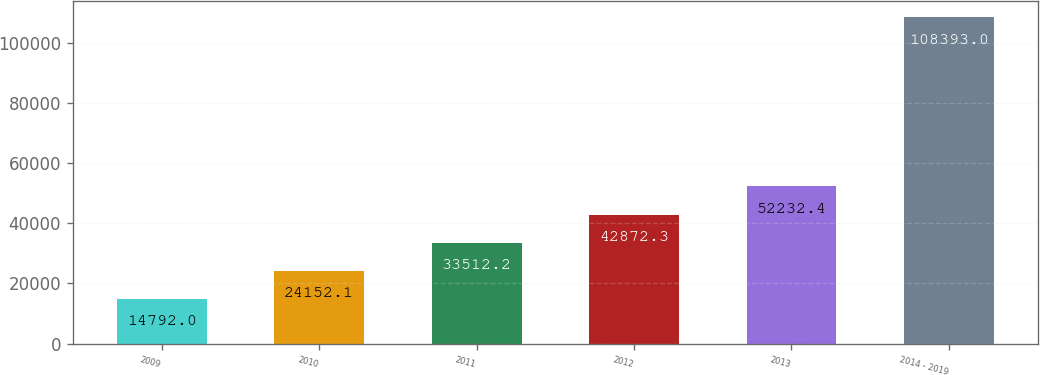<chart> <loc_0><loc_0><loc_500><loc_500><bar_chart><fcel>2009<fcel>2010<fcel>2011<fcel>2012<fcel>2013<fcel>2014 - 2019<nl><fcel>14792<fcel>24152.1<fcel>33512.2<fcel>42872.3<fcel>52232.4<fcel>108393<nl></chart> 